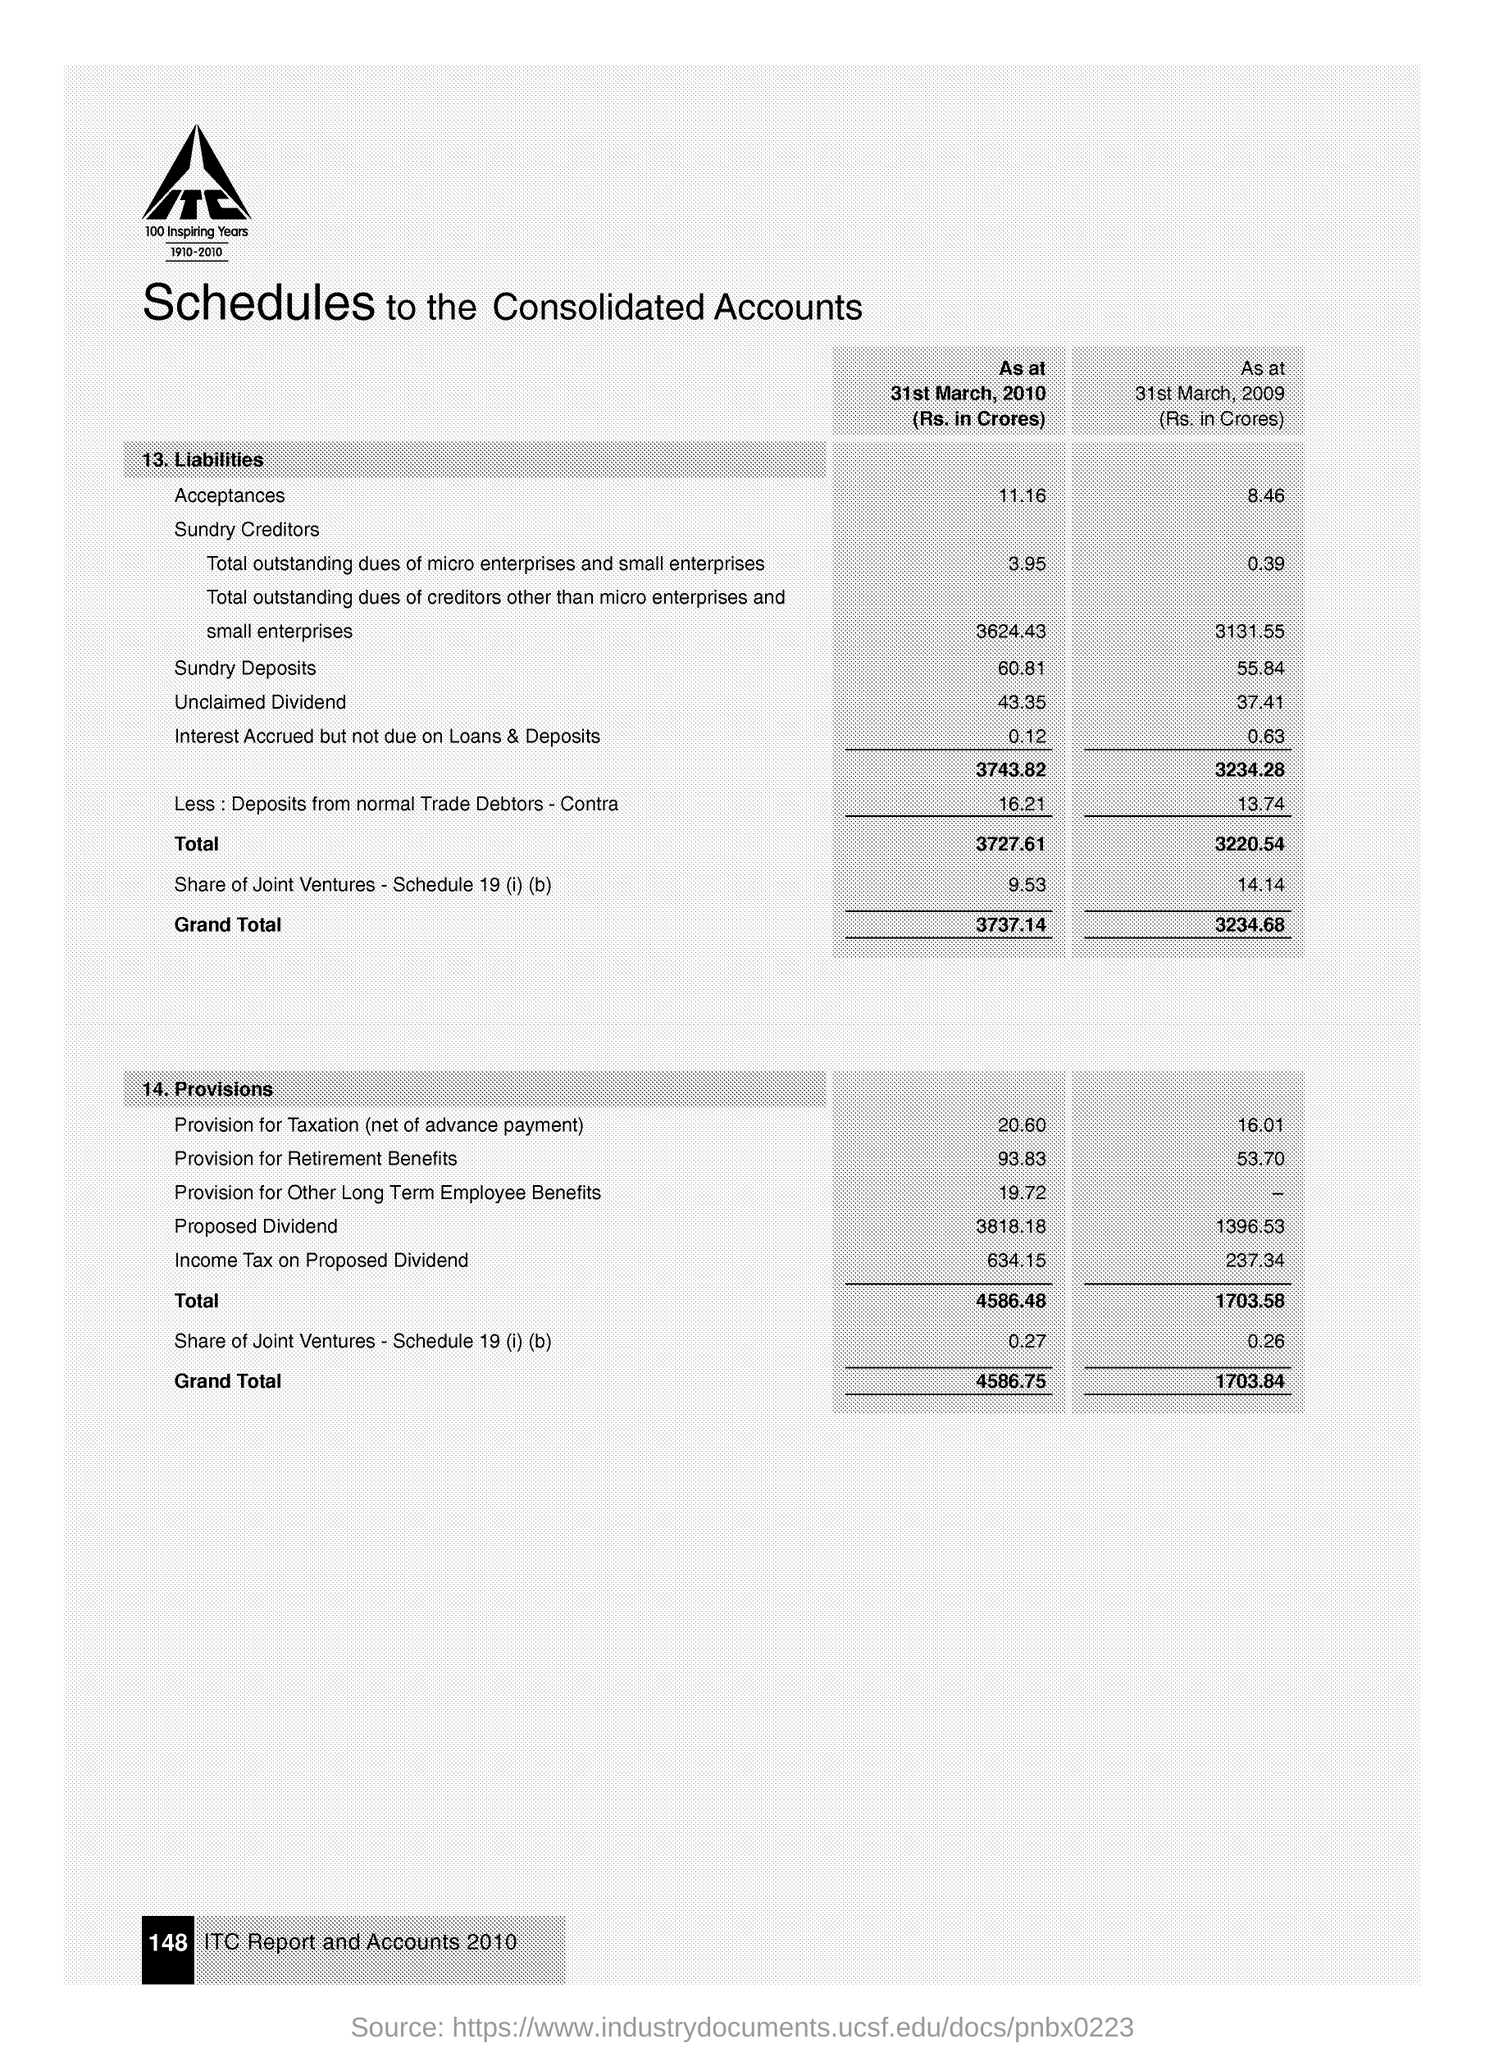What is the acceptance in liabilities as on 31st March 2010?
Your answer should be compact. 11.16. What is the sundry deposits in liabilities as on 31st March 2009?
Ensure brevity in your answer.  55.84. What is the grand total of liabilities  as on 31st March 2009?
Your answer should be very brief. 3234.68. What is the total of provisions as on 31-3-2010?
Your response must be concise. 4586.48. 